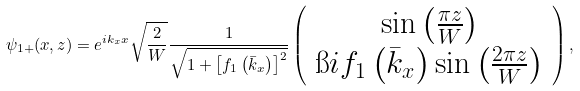Convert formula to latex. <formula><loc_0><loc_0><loc_500><loc_500>\psi _ { 1 + } ( x , z ) = e ^ { i k _ { x } x } \sqrt { \frac { 2 } { W } } \frac { 1 } { \sqrt { 1 + \left [ f _ { 1 } \left ( { \bar { k } } _ { x } \right ) \right ] ^ { 2 } } } \left ( \begin{array} { c } \sin \left ( \frac { \pi z } { W } \right ) \\ \i i f _ { 1 } \left ( { \bar { k } } _ { x } \right ) \sin \left ( \frac { 2 \pi z } { W } \right ) \end{array} \right ) ,</formula> 